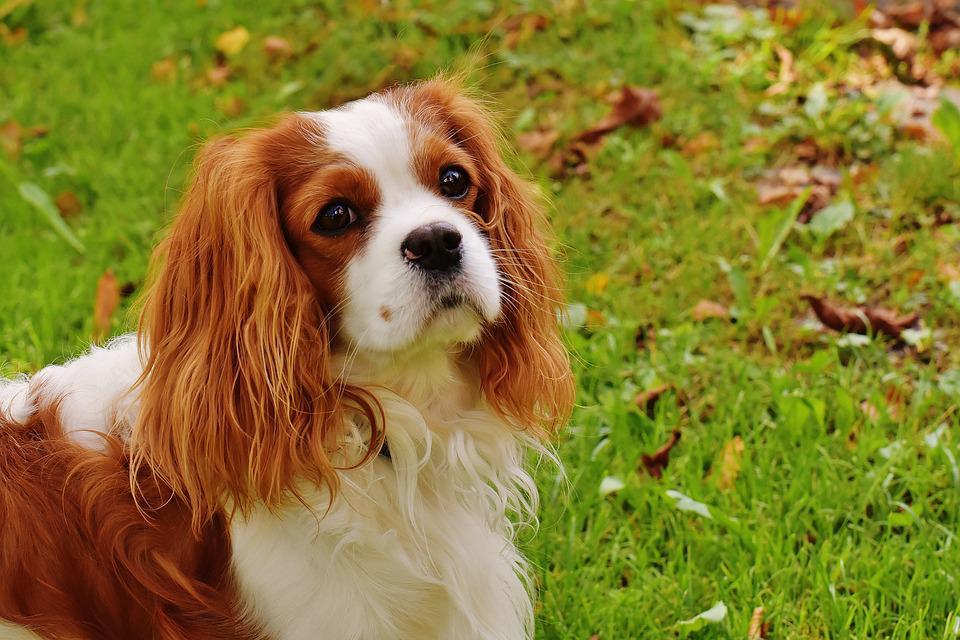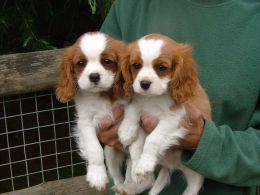The first image is the image on the left, the second image is the image on the right. Analyze the images presented: Is the assertion "Right image shows a brown and white spaniel on the grass." valid? Answer yes or no. No. 